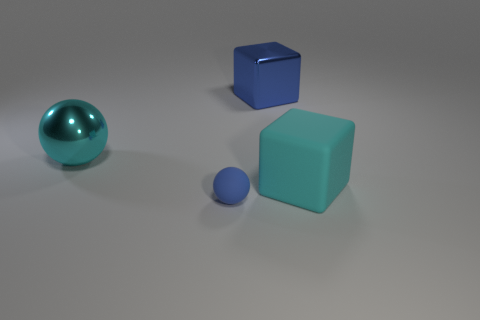Add 3 tiny blue metal cylinders. How many objects exist? 7 Add 3 tiny spheres. How many tiny spheres are left? 4 Add 1 big cyan shiny spheres. How many big cyan shiny spheres exist? 2 Subtract 0 green blocks. How many objects are left? 4 Subtract all tiny brown rubber things. Subtract all rubber cubes. How many objects are left? 3 